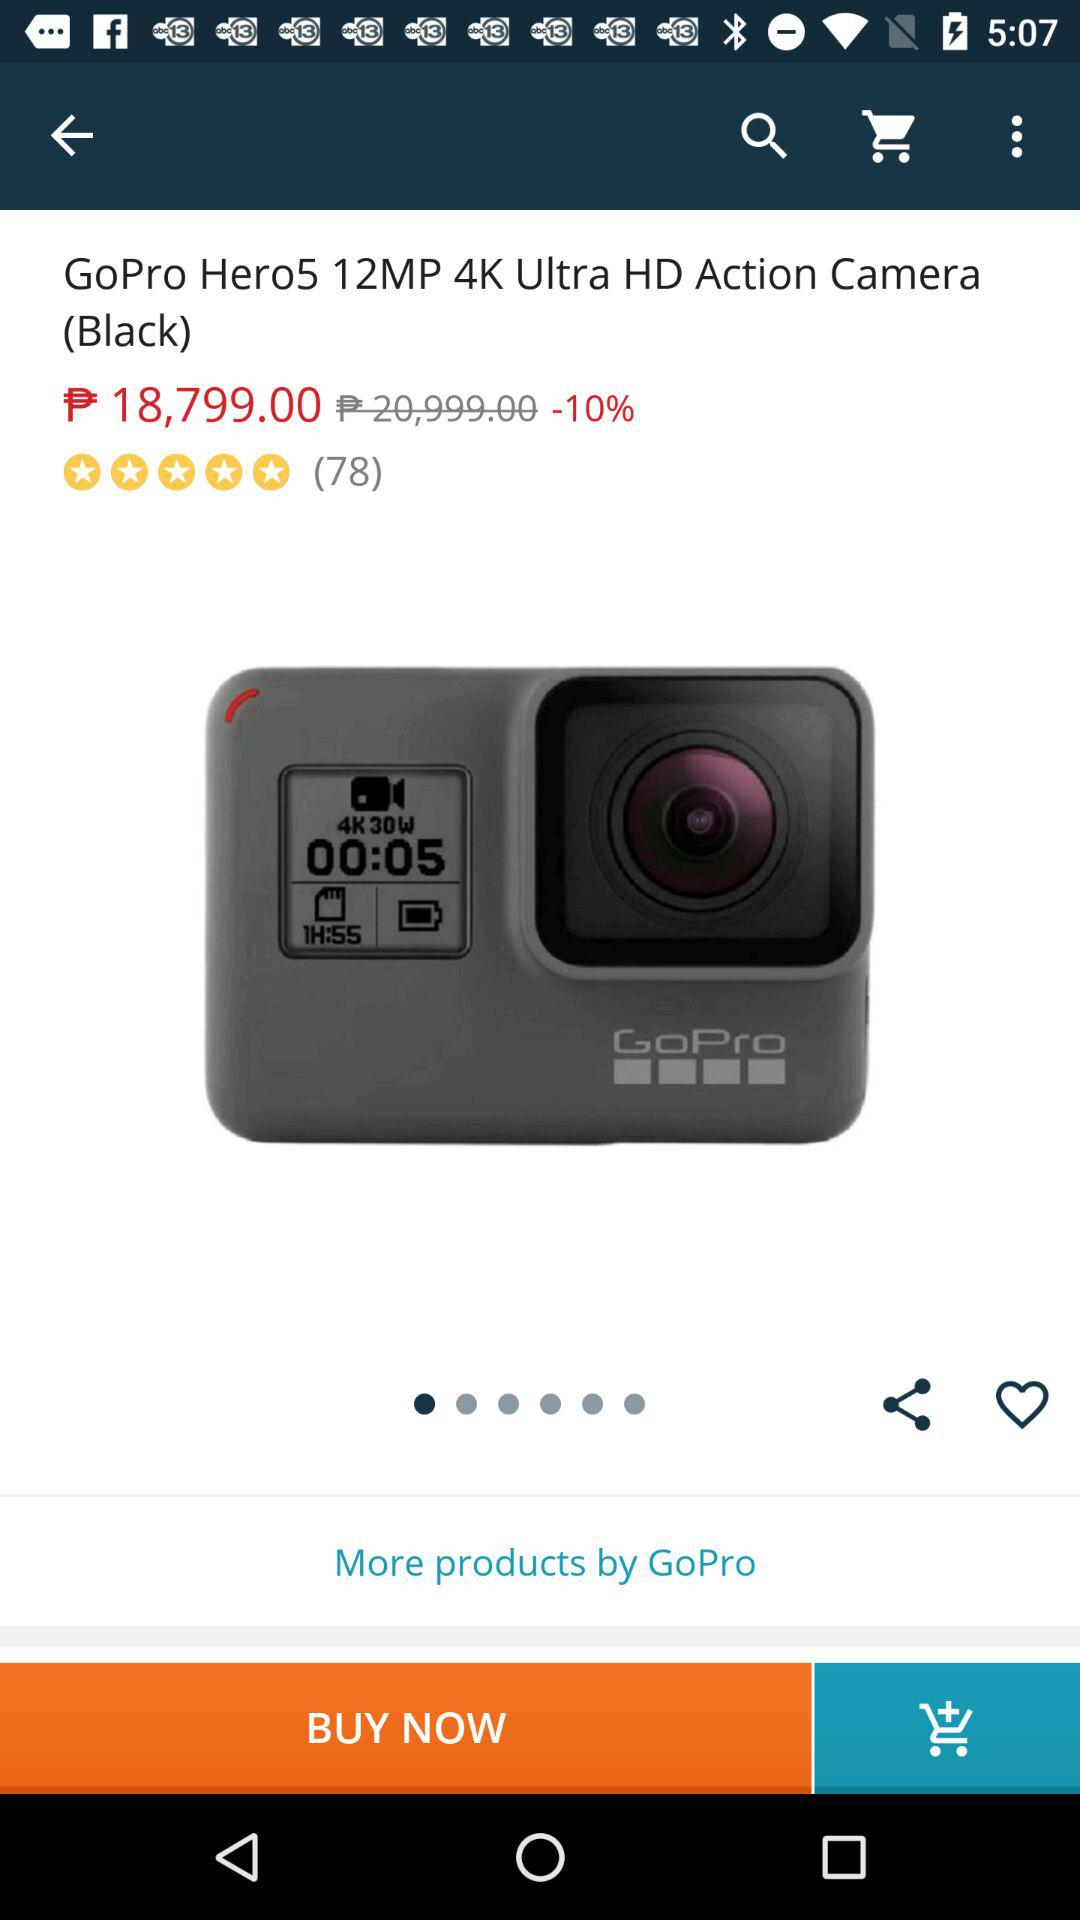What is the actual price of the device? The actual price is ₱20,999. 